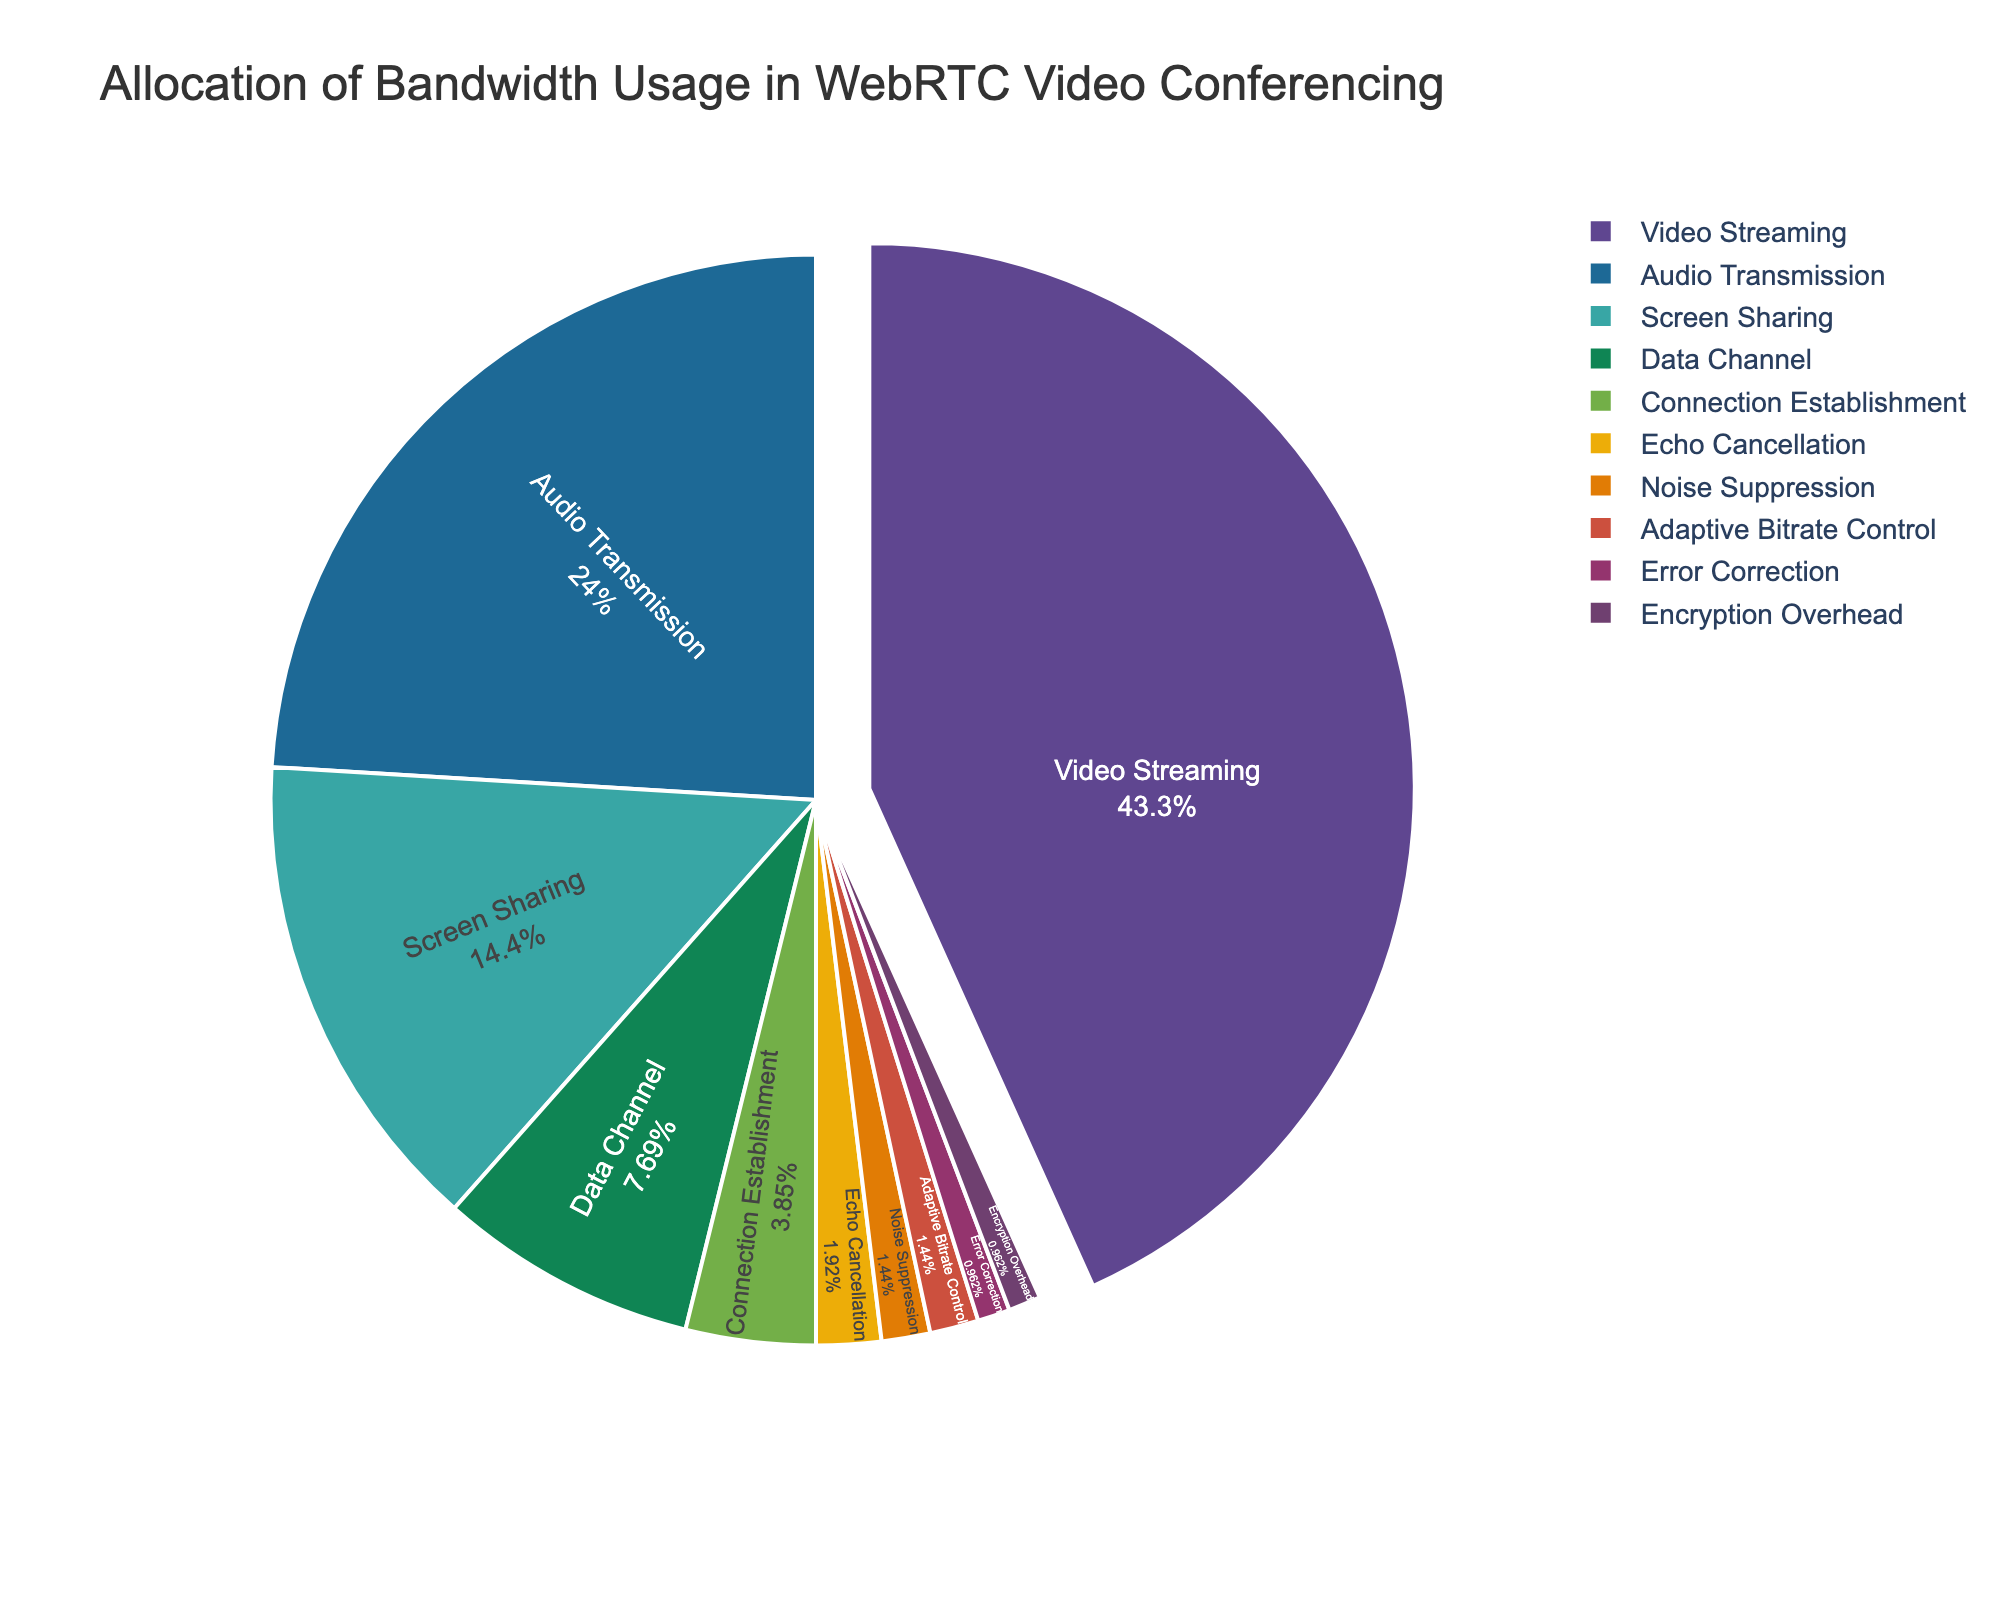What feature consumes the most bandwidth in WebRTC video conferencing? By looking at the pie chart, the largest slice represents the feature with the highest percentage. In this case, it's "Video Streaming" with 45%.
Answer: Video Streaming Which feature has the lowest bandwidth usage? The smallest slice in the pie chart represents the feature with the lowest percentage. Here, "Noise Suppression" has the smallest slice with 1.5%.
Answer: Noise Suppression How much more bandwidth does Video Streaming use compared to Audio Transmission? Find the percentages for Video Streaming (45%) and Audio Transmission (25%) in the pie chart. Subtract the percentage of Audio Transmission from Video Streaming to get the difference (45% - 25% = 20%).
Answer: 20% What is the combined bandwidth usage of Screen Sharing and Data Channel? Look for the slices representing Screen Sharing (15%) and Data Channel (8%) in the pie chart. Add these percentages together (15% + 8% = 23%).
Answer: 23% Which features collectively make up less than 10% of the total bandwidth usage? Identify the slices that sum up to less than 10%. These are Connection Establishment (4%), Echo Cancellation (2%), Noise Suppression (1.5%), Adaptive Bitrate Control (1.5%), Error Correction (1%), and Encryption Overhead (1%).
Answer: Connection Establishment, Echo Cancellation, Noise Suppression, Adaptive Bitrate Control, Error Correction, Encryption Overhead How does the bandwidth usage of Data Channel compare to Adaptive Bitrate Control? Identify the slices for Data Channel (8%) and Adaptive Bitrate Control (1.5%). Data Channel uses more bandwidth than Adaptive Bitrate Control.
Answer: Data Channel uses more What percentage of bandwidth usage is allocated to features other than Video Streaming and Audio Transmission? Identify the slices other than Video Streaming (45%) and Audio Transmission (25%). Sum the percentages of the remaining slices (15% + 8% + 4% + 2% + 1.5% + 1.5% + 1% + 1% = 34%).
Answer: 34% If Video Streaming were to reduce its bandwidth usage by 10%, what would its new percentage be? Identify the current percentage of Video Streaming (45%). Subtract 10% of 45 from 45 (45 - 4.5 = 40.5%).
Answer: 40.5% What is the median percentage of bandwidth usage among the features? List the percentages in ascending order: 1, 1, 1.5, 1.5, 2, 4, 8, 15, 25, 45. The median is the middle value, so between the 5th and 6th values (2 and 4). The median is (2 + 4) / 2 = 3.
Answer: 3 